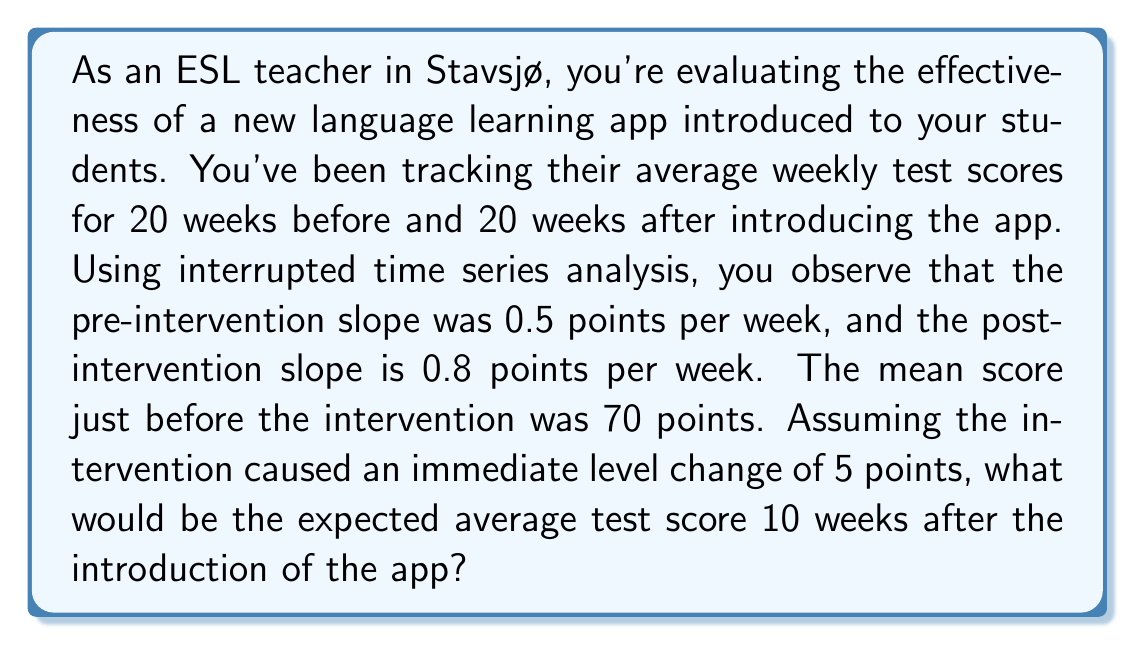What is the answer to this math problem? To solve this problem, we'll use the interrupted time series analysis model. The model can be represented as:

$$Y_t = \beta_0 + \beta_1 \cdot t + \beta_2 \cdot X_t + \beta_3 \cdot (t - t_0) \cdot X_t + \epsilon_t$$

Where:
- $Y_t$ is the outcome at time $t$
- $\beta_0$ is the baseline level at $t=0$
- $\beta_1$ is the slope before the intervention
- $\beta_2$ is the level change after the intervention
- $\beta_3$ is the change in slope after the intervention
- $X_t$ is a dummy variable (0 before intervention, 1 after)
- $t_0$ is the time of intervention
- $\epsilon_t$ is the error term

Given:
- Pre-intervention slope ($\beta_1$) = 0.5 points/week
- Post-intervention slope = 0.8 points/week
- Mean score just before intervention = 70 points
- Immediate level change ($\beta_2$) = 5 points
- We want to predict the score 10 weeks after intervention

Steps:
1. Calculate $\beta_3$ (change in slope):
   $\beta_3 = 0.8 - 0.5 = 0.3$ points/week

2. Set up the equation for 10 weeks after intervention:
   $Y_{30} = \beta_0 + \beta_1 \cdot 30 + \beta_2 \cdot 1 + \beta_3 \cdot 10 \cdot 1$

3. Calculate $\beta_0$ (baseline level at $t=0$):
   $70 = \beta_0 + 0.5 \cdot 20$
   $\beta_0 = 70 - 10 = 60$

4. Plug in the values:
   $Y_{30} = 60 + 0.5 \cdot 30 + 5 + 0.3 \cdot 10$

5. Solve the equation:
   $Y_{30} = 60 + 15 + 5 + 3 = 83$

Therefore, the expected average test score 10 weeks after the introduction of the app would be 83 points.
Answer: 83 points 